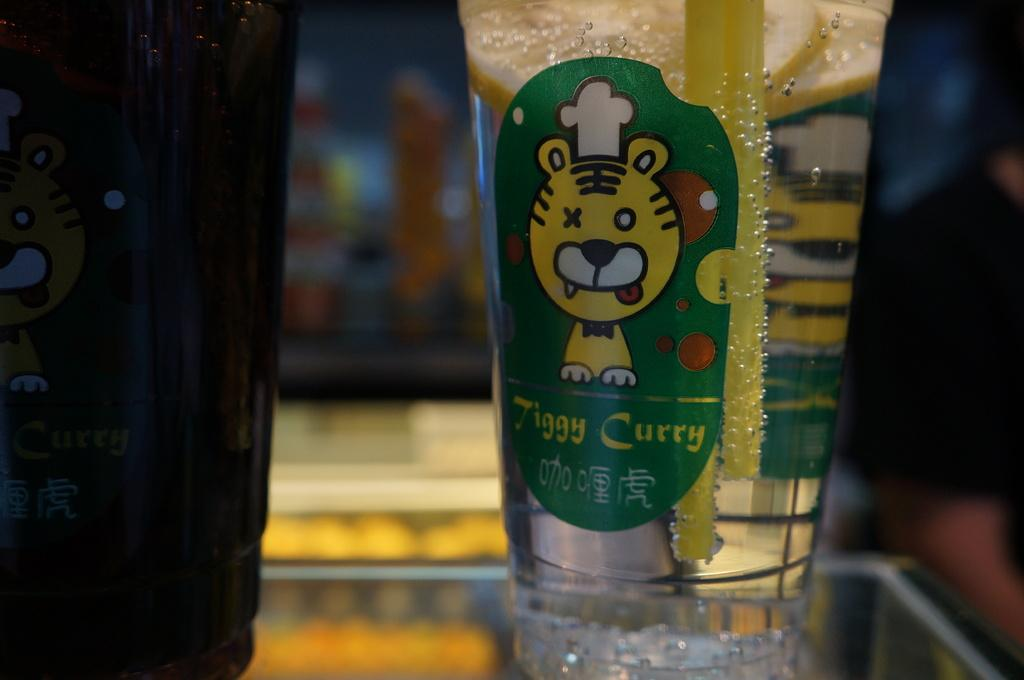What objects are on the table in the image? There are glasses on a table in the image. Can you describe the background of the image? The background of the image is blurred. What type of pet can be seen in the image? There is no pet present in the image. 